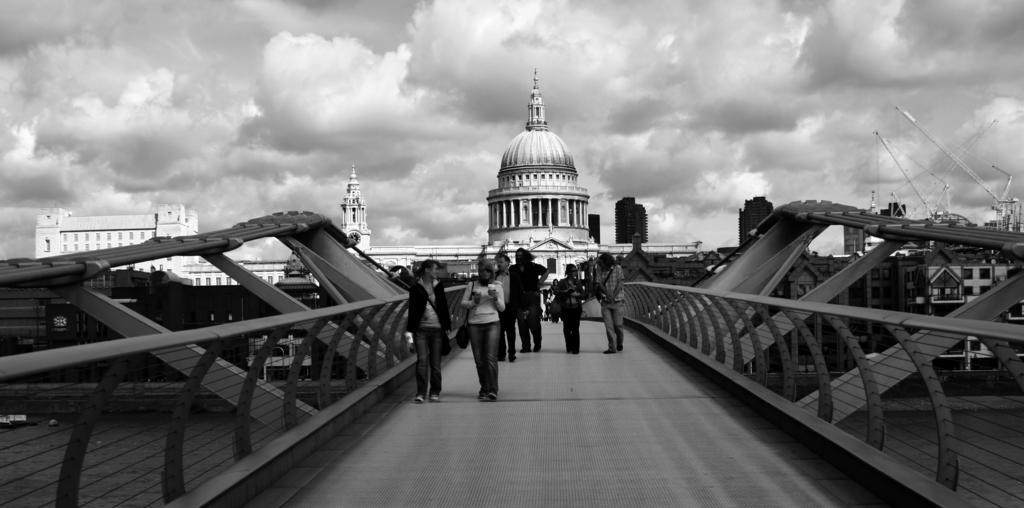Describe this image in one or two sentences. In this picture there is a bridge in the center of the image and there are people on it, there are boundaries on the right and left side of the image and here is a building in the center of the image and there are other buildings in the background area of the image, there are towers on the right side of the image. 